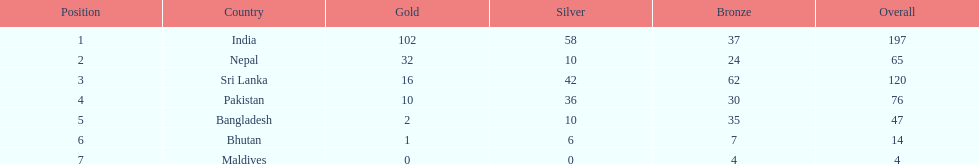How many gold medals were awarded between all 7 nations? 163. 